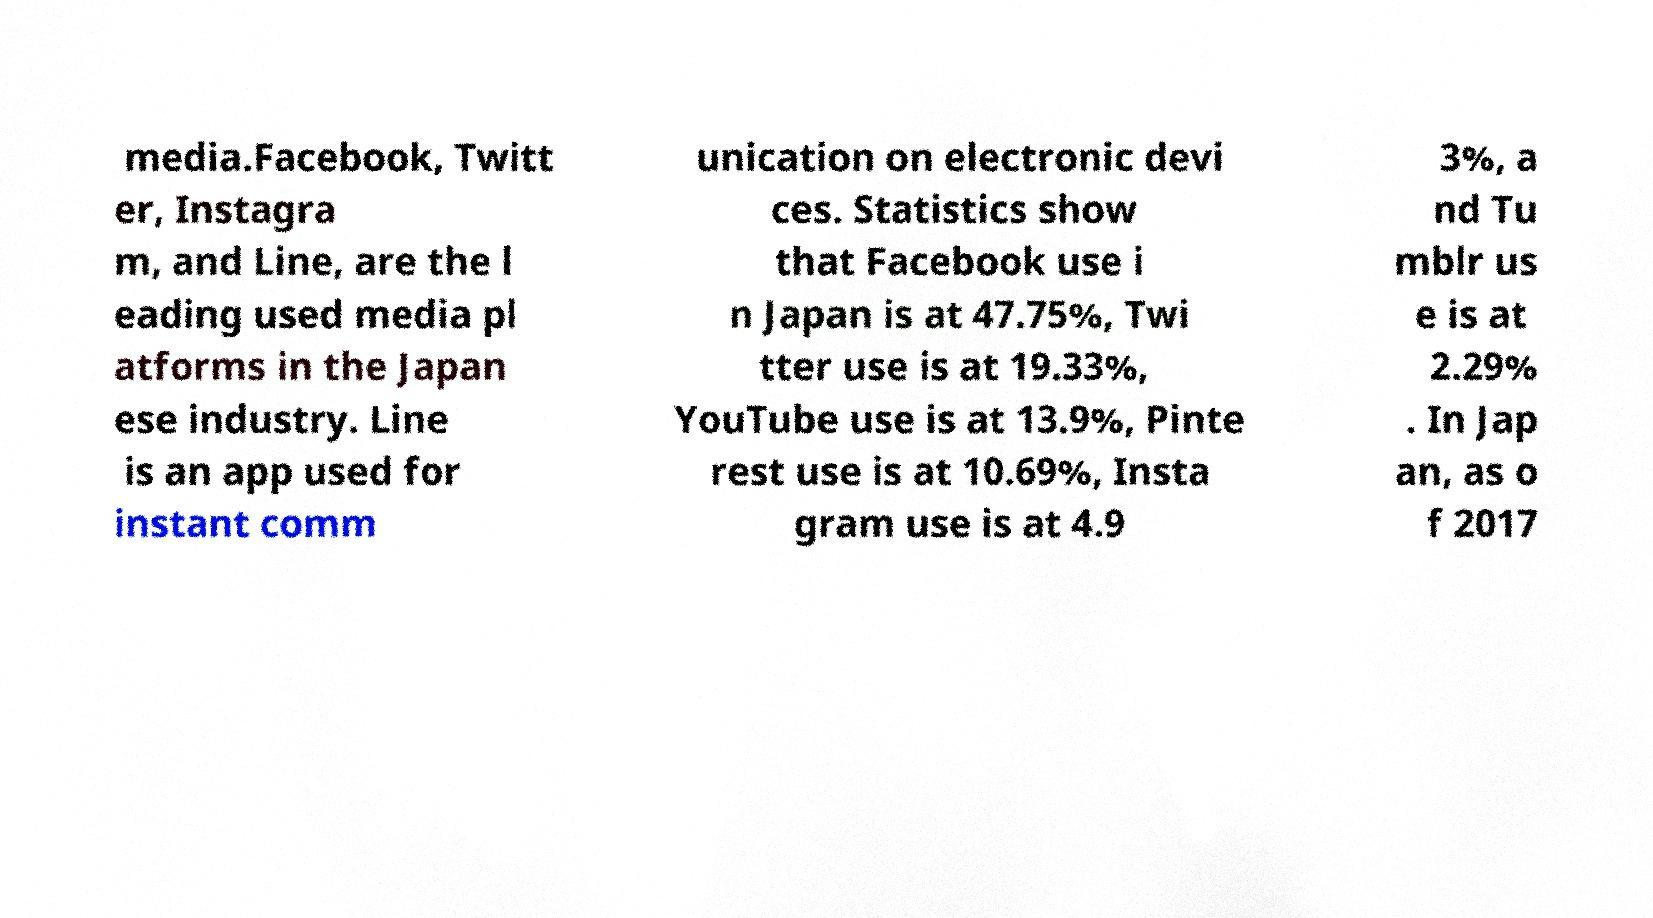There's text embedded in this image that I need extracted. Can you transcribe it verbatim? media.Facebook, Twitt er, Instagra m, and Line, are the l eading used media pl atforms in the Japan ese industry. Line is an app used for instant comm unication on electronic devi ces. Statistics show that Facebook use i n Japan is at 47.75%, Twi tter use is at 19.33%, YouTube use is at 13.9%, Pinte rest use is at 10.69%, Insta gram use is at 4.9 3%, a nd Tu mblr us e is at 2.29% . In Jap an, as o f 2017 